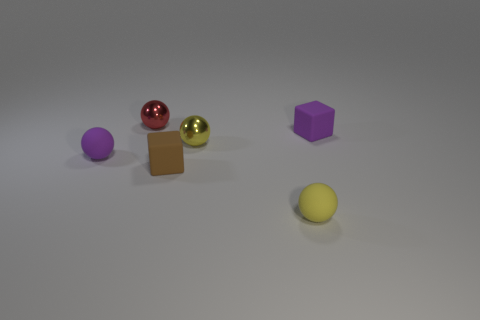Subtract all purple rubber balls. How many balls are left? 3 Add 3 yellow balls. How many objects exist? 9 Subtract all purple cubes. How many yellow balls are left? 2 Subtract 1 spheres. How many spheres are left? 3 Subtract all purple blocks. How many blocks are left? 1 Subtract all spheres. How many objects are left? 2 Subtract all tiny brown metallic blocks. Subtract all tiny objects. How many objects are left? 0 Add 6 purple spheres. How many purple spheres are left? 7 Add 3 red spheres. How many red spheres exist? 4 Subtract 0 gray cubes. How many objects are left? 6 